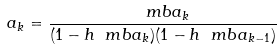<formula> <loc_0><loc_0><loc_500><loc_500>a _ { k } = \frac { \ m b a _ { k } } { ( 1 - h \ m b a _ { k } ) ( 1 - h \ m b a _ { k - 1 } ) }</formula> 